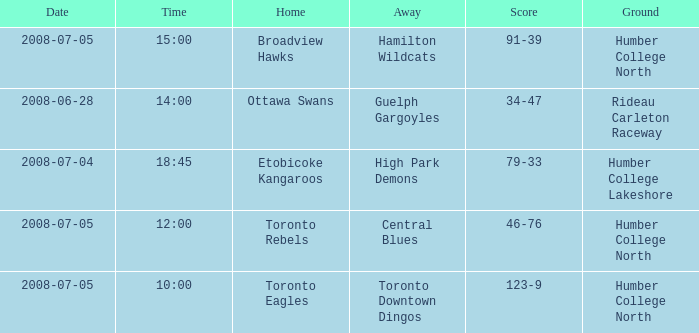What is the Date with a Time that is 18:45? 2008-07-04. 